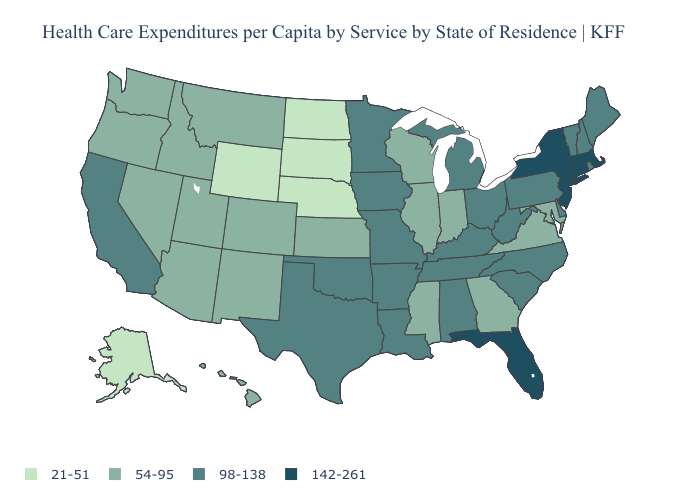What is the value of Alabama?
Quick response, please. 98-138. Name the states that have a value in the range 98-138?
Give a very brief answer. Alabama, Arkansas, California, Delaware, Iowa, Kentucky, Louisiana, Maine, Michigan, Minnesota, Missouri, New Hampshire, North Carolina, Ohio, Oklahoma, Pennsylvania, Rhode Island, South Carolina, Tennessee, Texas, Vermont, West Virginia. What is the lowest value in the MidWest?
Give a very brief answer. 21-51. Among the states that border Maryland , does Pennsylvania have the highest value?
Quick response, please. Yes. Which states have the lowest value in the USA?
Give a very brief answer. Alaska, Nebraska, North Dakota, South Dakota, Wyoming. Does Alaska have the lowest value in the USA?
Give a very brief answer. Yes. Does Kansas have the highest value in the MidWest?
Keep it brief. No. What is the value of New Jersey?
Short answer required. 142-261. Does Wyoming have the lowest value in the USA?
Answer briefly. Yes. Does Massachusetts have the highest value in the USA?
Quick response, please. Yes. Among the states that border Alabama , does Mississippi have the lowest value?
Write a very short answer. Yes. Name the states that have a value in the range 54-95?
Short answer required. Arizona, Colorado, Georgia, Hawaii, Idaho, Illinois, Indiana, Kansas, Maryland, Mississippi, Montana, Nevada, New Mexico, Oregon, Utah, Virginia, Washington, Wisconsin. Name the states that have a value in the range 21-51?
Give a very brief answer. Alaska, Nebraska, North Dakota, South Dakota, Wyoming. Which states have the lowest value in the USA?
Short answer required. Alaska, Nebraska, North Dakota, South Dakota, Wyoming. Name the states that have a value in the range 54-95?
Write a very short answer. Arizona, Colorado, Georgia, Hawaii, Idaho, Illinois, Indiana, Kansas, Maryland, Mississippi, Montana, Nevada, New Mexico, Oregon, Utah, Virginia, Washington, Wisconsin. 